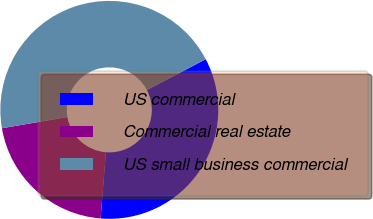Convert chart. <chart><loc_0><loc_0><loc_500><loc_500><pie_chart><fcel>US commercial<fcel>Commercial real estate<fcel>US small business commercial<nl><fcel>33.97%<fcel>21.03%<fcel>44.99%<nl></chart> 